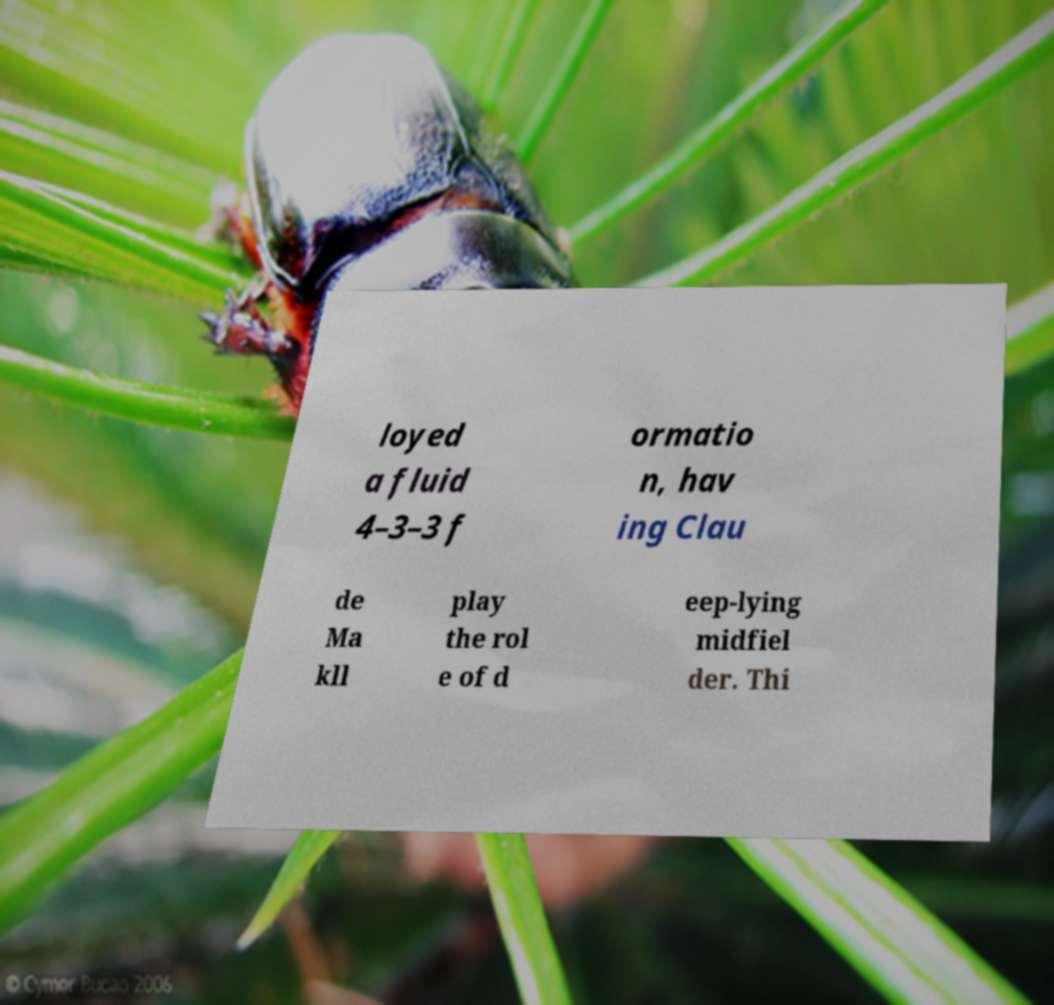Could you extract and type out the text from this image? loyed a fluid 4–3–3 f ormatio n, hav ing Clau de Ma kll play the rol e of d eep-lying midfiel der. Thi 